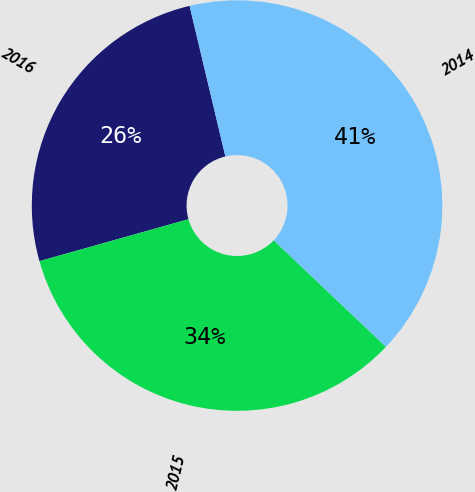<chart> <loc_0><loc_0><loc_500><loc_500><pie_chart><fcel>2016<fcel>2015<fcel>2014<nl><fcel>25.65%<fcel>33.55%<fcel>40.79%<nl></chart> 